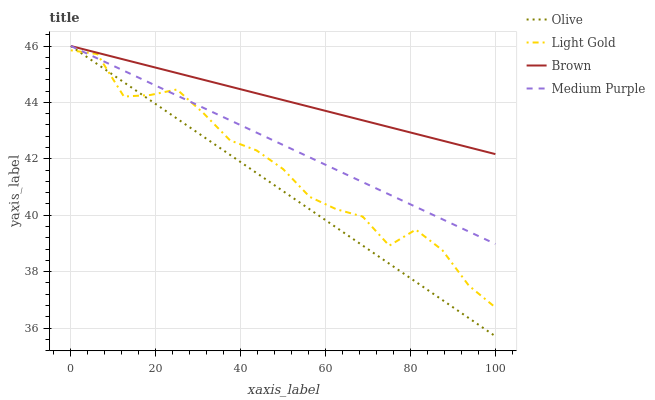Does Olive have the minimum area under the curve?
Answer yes or no. Yes. Does Brown have the maximum area under the curve?
Answer yes or no. Yes. Does Medium Purple have the minimum area under the curve?
Answer yes or no. No. Does Medium Purple have the maximum area under the curve?
Answer yes or no. No. Is Brown the smoothest?
Answer yes or no. Yes. Is Light Gold the roughest?
Answer yes or no. Yes. Is Medium Purple the smoothest?
Answer yes or no. No. Is Medium Purple the roughest?
Answer yes or no. No. Does Olive have the lowest value?
Answer yes or no. Yes. Does Medium Purple have the lowest value?
Answer yes or no. No. Does Medium Purple have the highest value?
Answer yes or no. Yes. Does Light Gold have the highest value?
Answer yes or no. No. Is Light Gold less than Brown?
Answer yes or no. Yes. Is Brown greater than Light Gold?
Answer yes or no. Yes. Does Light Gold intersect Olive?
Answer yes or no. Yes. Is Light Gold less than Olive?
Answer yes or no. No. Is Light Gold greater than Olive?
Answer yes or no. No. Does Light Gold intersect Brown?
Answer yes or no. No. 